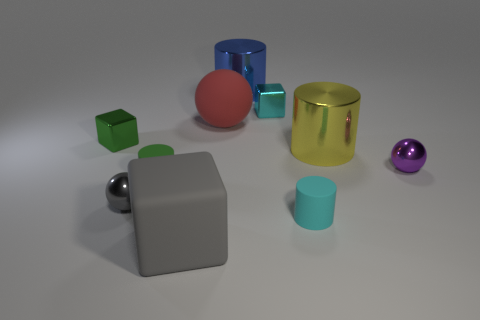Subtract all gray balls. How many balls are left? 2 Subtract all small purple spheres. How many spheres are left? 2 Subtract 2 balls. How many balls are left? 1 Subtract all balls. How many objects are left? 7 Subtract all cyan blocks. Subtract all tiny green blocks. How many objects are left? 8 Add 6 gray matte things. How many gray matte things are left? 7 Add 3 large yellow spheres. How many large yellow spheres exist? 3 Subtract 1 purple spheres. How many objects are left? 9 Subtract all yellow cylinders. Subtract all red cubes. How many cylinders are left? 3 Subtract all blue blocks. How many purple cylinders are left? 0 